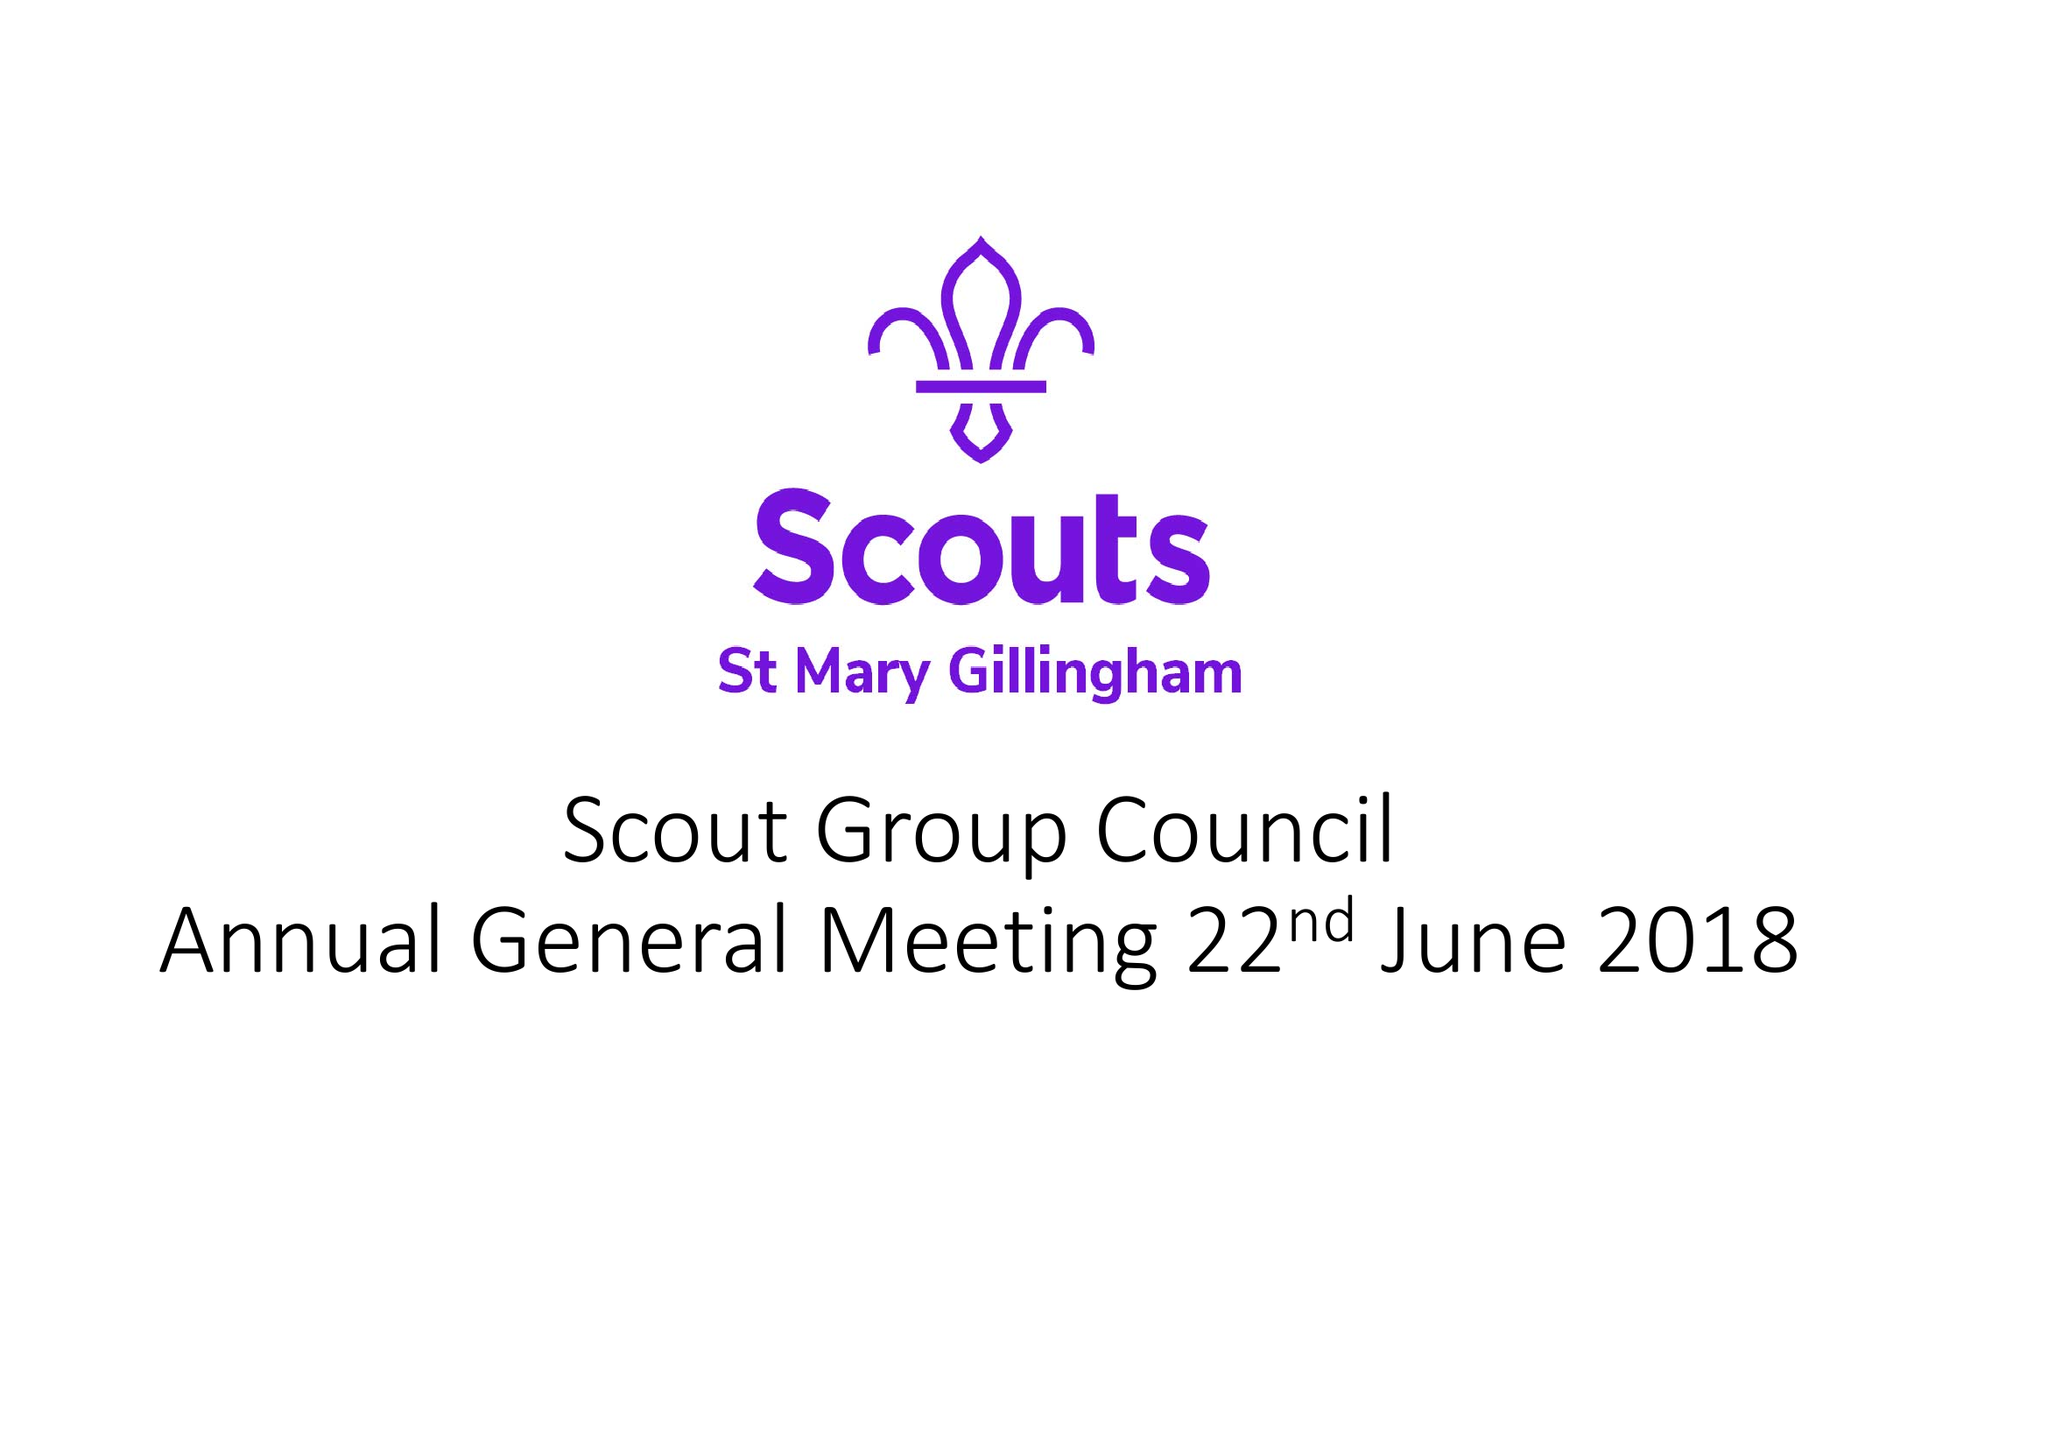What is the value for the charity_name?
Answer the question using a single word or phrase. Scouts St Mary Gillingham 